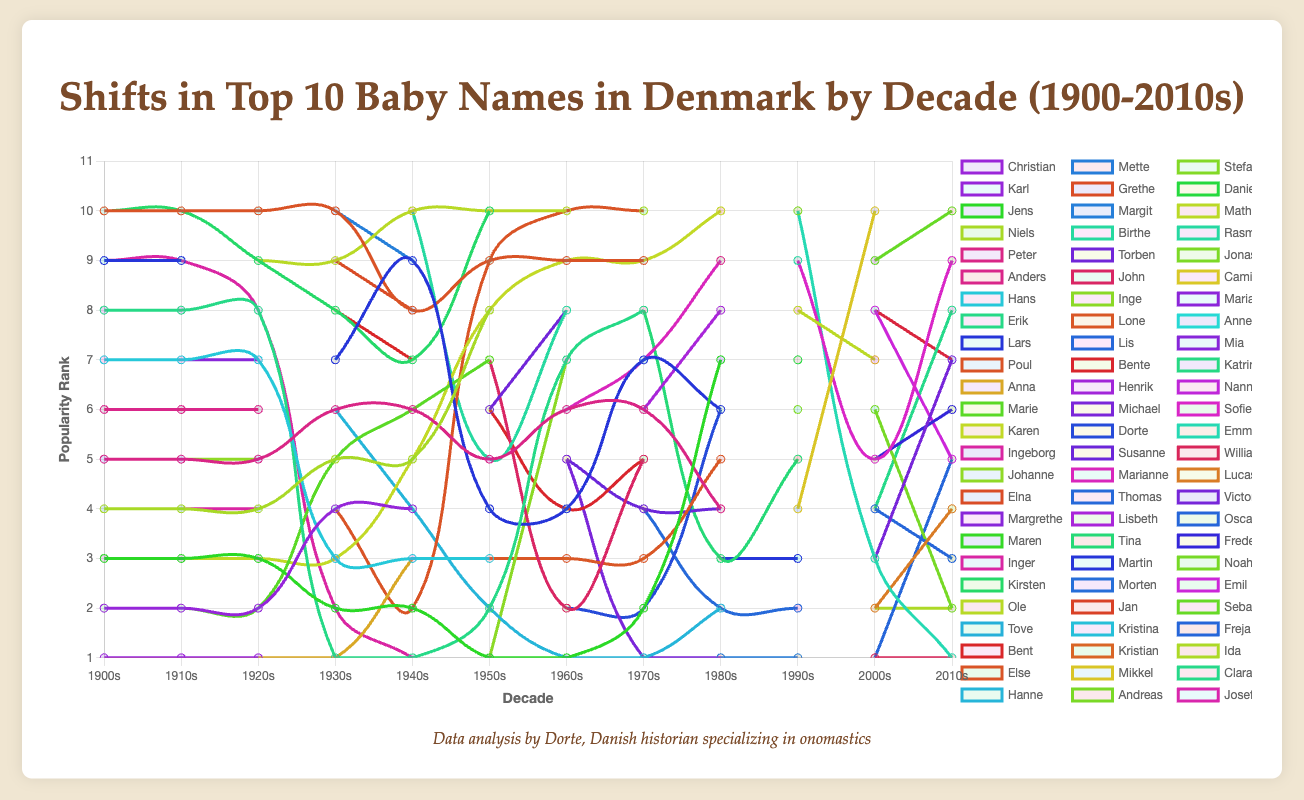Which name appears consistently in the top 10 for girls across most decades? To find the name that consistently appears, check each decade's top 10 list for girls. "Karen" is present in every decade from the 1900s to the 1970s.
Answer: Karen Which boys' name saw a significant decline in popularity post-1920s? Compare the rank of the boys' names across the decades. "Christian" drops out of the top 10 entirely after the 1920s.
Answer: Christian Which decade saw the introduction of the name "John" in the top 10 for boys? Look for when "John" first appears in the top 10 list for boys. It appears in the 1950s.
Answer: 1950s In which decade did "Hanne" reach its highest popularity for girls? Analyze the rank of "Hanne" across the decades. "Hanne" ranks highest in the 1930s as it is listed third.
Answer: 1930s Compare the popularity of "Emma" for girls between the 1990s and 2010s. Has it increased, decreased, or stayed the same? Check the rank of "Emma" in the top 10 lists for both decades. "Emma" moves from 10th in the 1990s to 1st in the 2010s, so it has increased.
Answer: Increased What are the three most popular boys' names in the 2000s? Refer to the top 10 list for boys in the 2000s. The top three names are William, Lucas, and Victor.
Answer: William, Lucas, Victor Which girls' name first appears in the top 10 in the 1990s and remains popular into the 2000s and 2010s? Identify new entries in the 1990s and check if they are still present in subsequent decades. “Emma” appears in the 1990s and remains in the top 10.
Answer: Emma How many names appear in the top 10 for boys in every single decade from 1900s to 2010s? Check each decade's list to count how many names are consistently present. “None” of the boys’ names appear in the top 10 across all decades.
Answer: None Which girls' name reaches a top 5 position for the first time in the 2000s? Check the girls' names that enter the top 5 for the first time in the 2000s. "Freja" appears and is third in the 2000s for the first time.
Answer: Freja What is the longest period that "Jens" remained in the top 10 for boys? Locate the first and last decade "Jens" appears in the boys' top 10 and count the number of consecutive decades. “Jens” remains for 11 decades from the 1900s to the 2000s.
Answer: 11 decades 